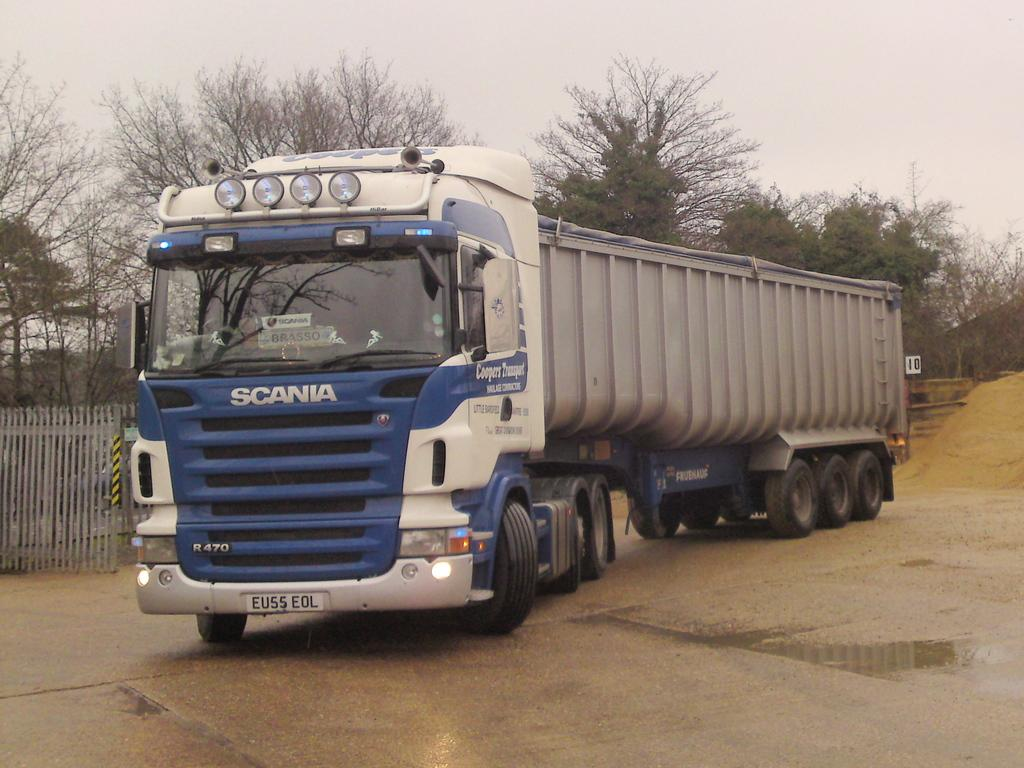What type of vehicle is on the road in the image? There is a truck on the road in the image. What is located on the left side of the image? There is a fence on the left side of the image. What can be seen in the background of the image? There are trees in the background of the image. What is visible at the top of the image? The sky is visible at the top of the image. What type of terrain is on the right side of the image? There is sand on the right side of the image. What type of waste is being disposed of in the image? There is no waste disposal activity depicted in the image. 